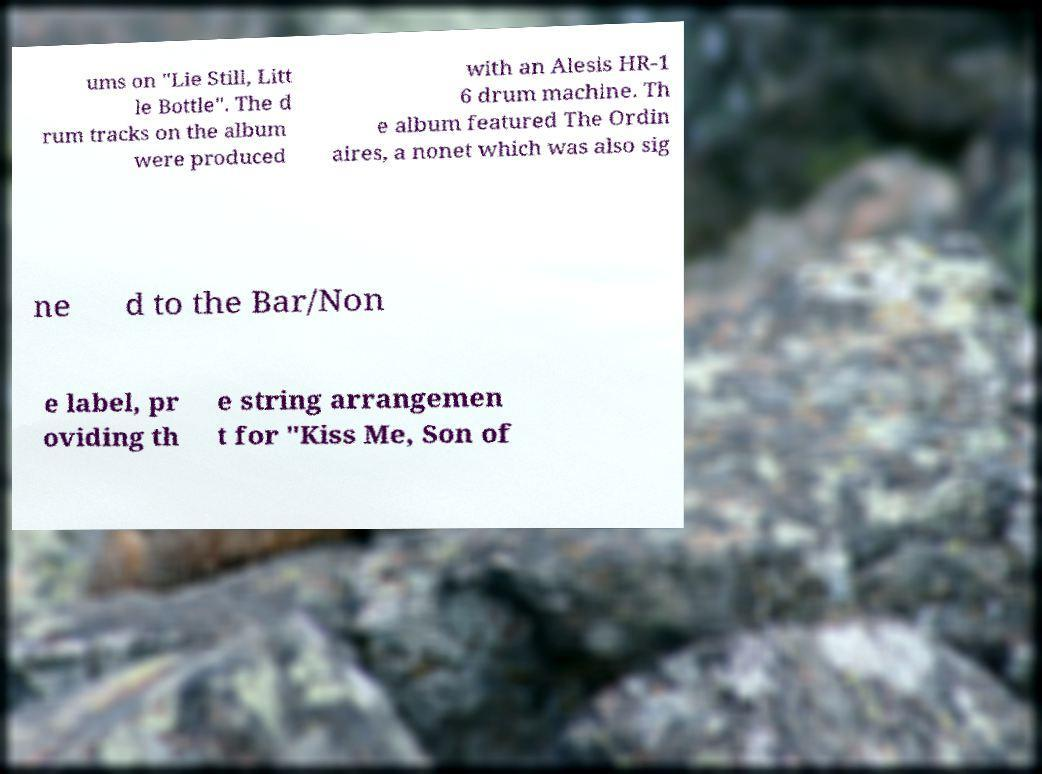Can you accurately transcribe the text from the provided image for me? ums on "Lie Still, Litt le Bottle". The d rum tracks on the album were produced with an Alesis HR-1 6 drum machine. Th e album featured The Ordin aires, a nonet which was also sig ne d to the Bar/Non e label, pr oviding th e string arrangemen t for "Kiss Me, Son of 